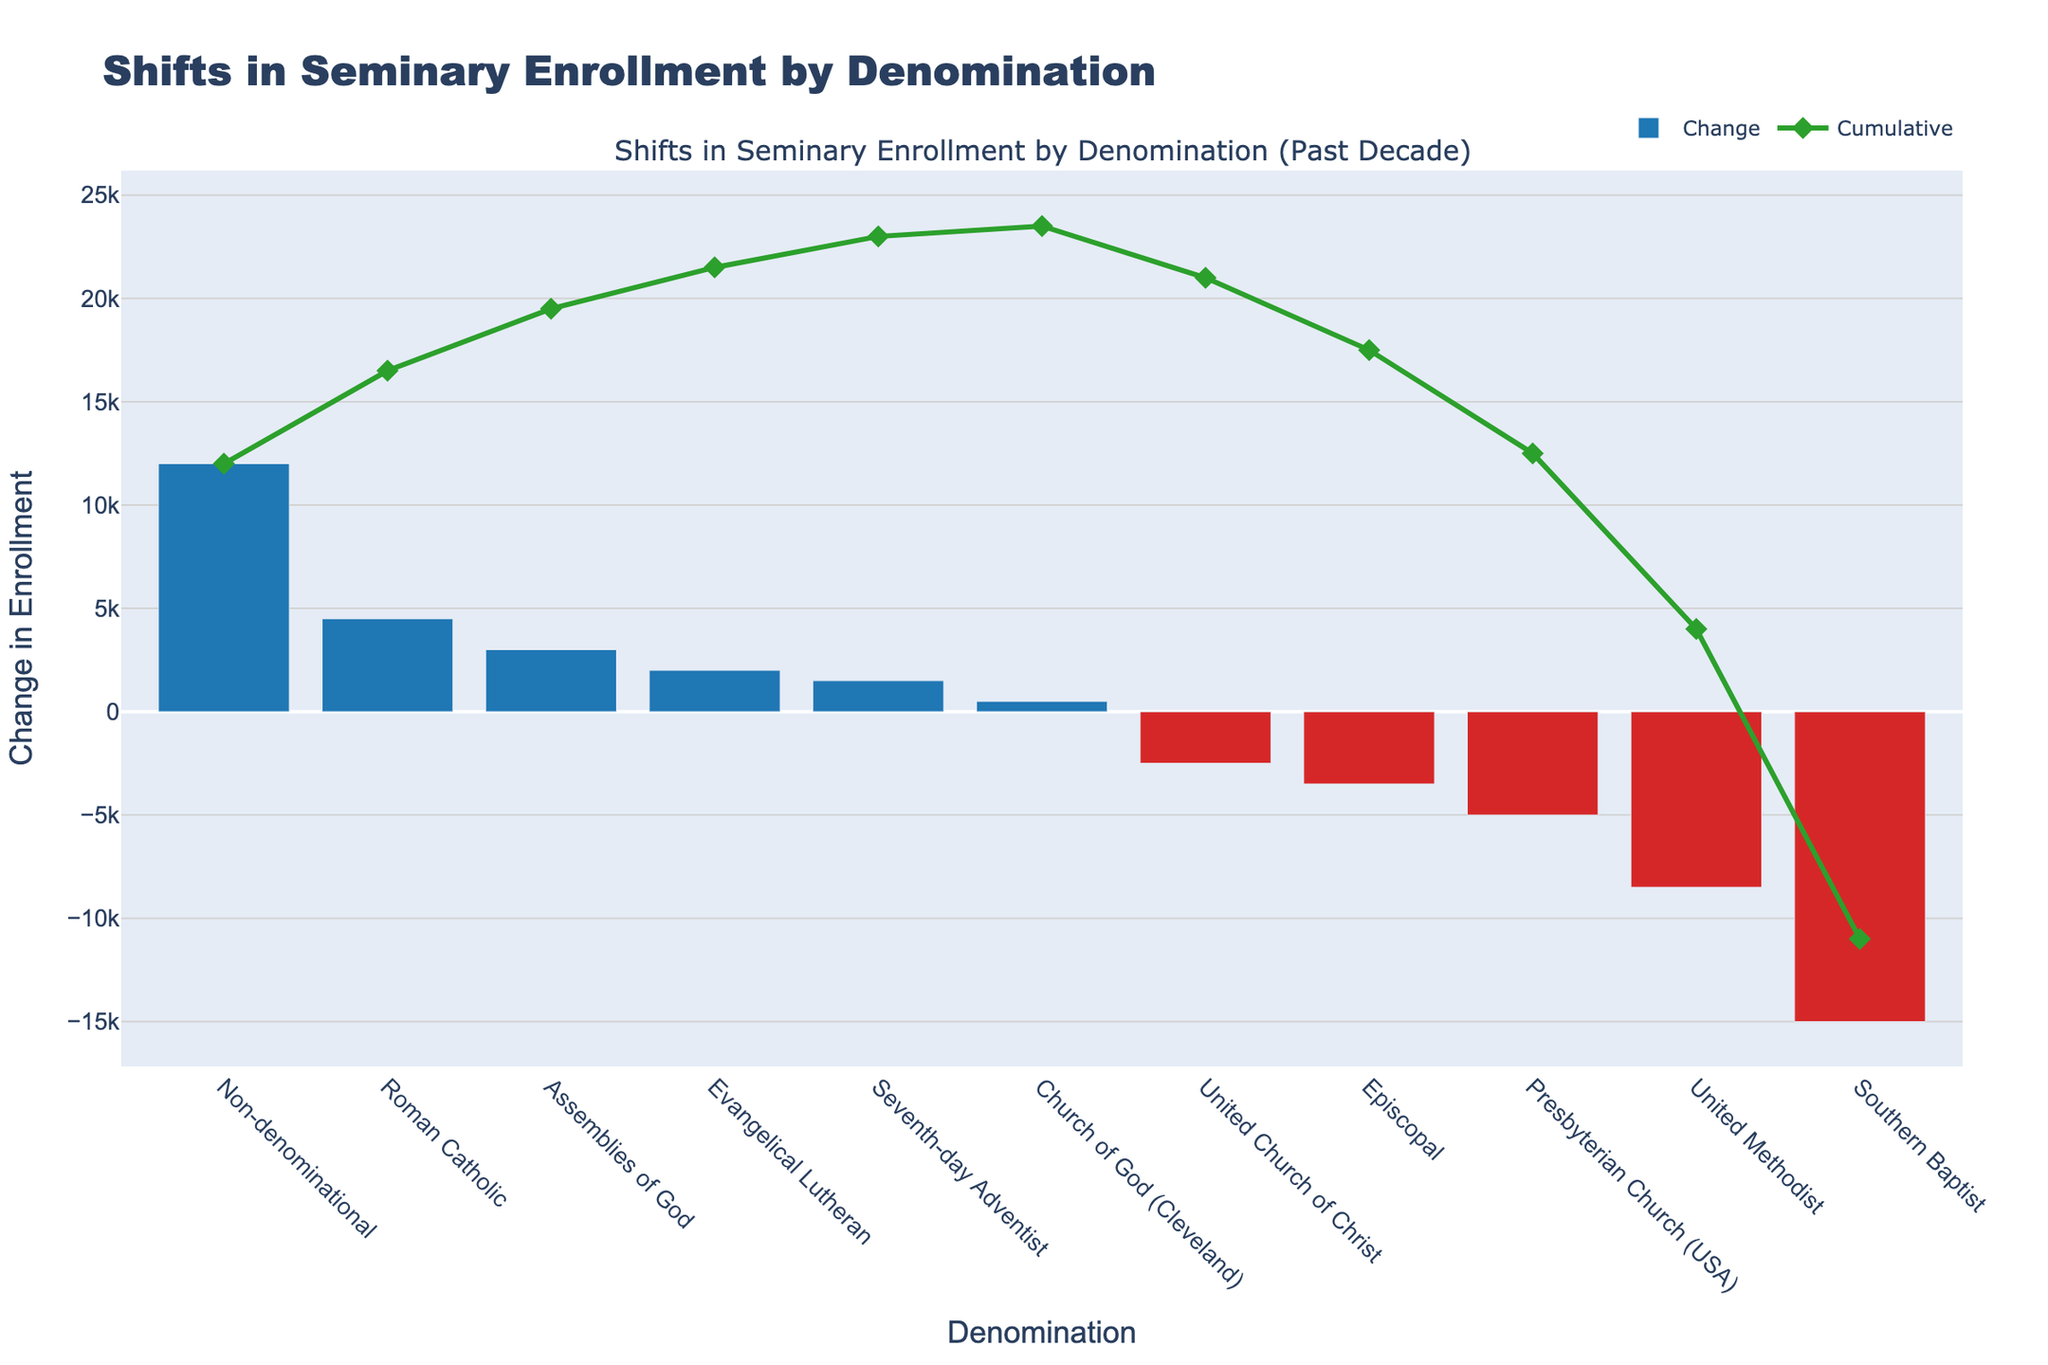What is the total change in seminary enrollment across all denominations shown? According to the data, the total change is -11,000. This is visually summarized by the ending position of the cumulative line, but it is explicitly stated in the data provided.
Answer: -11,000 Which denomination experienced the largest decrease in enrollment? The Southern Baptist denomination experienced the largest decrease in enrollment, as indicated by the bar with the most negative change (-15,000). This is easily observed by noting the longest downward bar in red.
Answer: Southern Baptist Which denomination had the highest positive change in enrollment? The Non-denominational category showed the highest positive change, which is 12,000. This is displayed as the tallest upward bar in blue.
Answer: Non-denominational How many denominations experienced a positive change in enrollment? By counting the number of blue bars, we find there are five denominations with a positive change: Evangelical Lutheran, Roman Catholic, Assemblies of God, Seventh-day Adventist, and Non-denominational.
Answer: Five What is the cumulative change after the first denomination (Southern Baptist) is considered? Starting with the largest negative change, the cumulation starts at -15,000, represented by the Southern Baptist bar and the starting point of the cumulative line.
Answer: -15,000 Which denomination caused the cumulative change to become positive? The cumulative change becomes positive with the inclusion of the Non-denominational denomination, adding a large positive change (12,000) after several smaller increments, indicated by the green cumulative line peaking at this point.
Answer: Non-denominational What is the cumulative change after adding the Evangelical Lutheran, Roman Catholic, Assemblies of God, and Non-denominational denominations? Adding their changes: 2,000 (Evangelical Lutheran) + 4,500 (Roman Catholic) + 3,000 (Assemblies of God) + 12,000 (Non-denominational) gives a cumulative change of 21,500.
Answer: 21,500 Which two denominations experienced the least negative change in enrollment? The Presbyterian Church (USA) and the United Church of Christ experienced the least negative changes at -5,000 and -2,500, respectively. This is observed by noting the two shortest downward bars in red.
Answer: Presbyterian Church (USA) and United Church of Christ How much did the Seventh-day Adventist denomination change by? The Seventh-day Adventist denomination had a change of 1,500 in enrollment as indicated by the shorter blue bar in the positive section.
Answer: 1,500 What is the cumulative change value after combining United Methodist, Presbyterian Church (USA), Episcopal, and United Church of Christ denominations? Adding their changes of -8,500 (United Methodist), -5,000 (Presbyterian Church (USA)), -3,500 (Episcopal), and -2,500 (United Church of Christ) results in a cumulative change of -19,500.
Answer: -19,500 